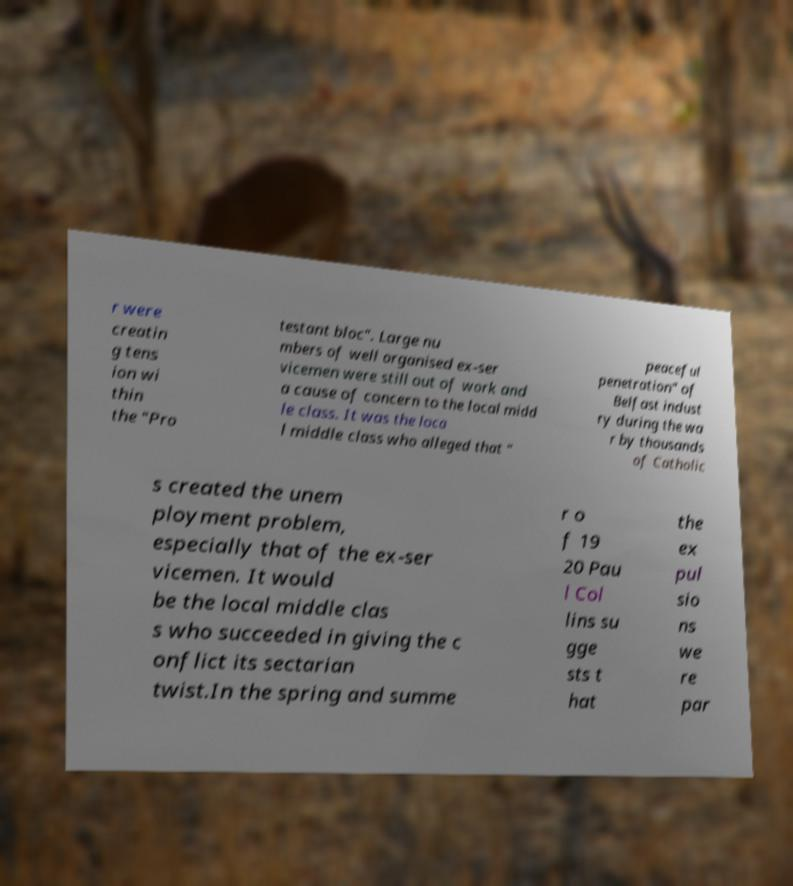Please read and relay the text visible in this image. What does it say? r were creatin g tens ion wi thin the "Pro testant bloc". Large nu mbers of well organised ex-ser vicemen were still out of work and a cause of concern to the local midd le class. It was the loca l middle class who alleged that " peaceful penetration" of Belfast indust ry during the wa r by thousands of Catholic s created the unem ployment problem, especially that of the ex-ser vicemen. It would be the local middle clas s who succeeded in giving the c onflict its sectarian twist.In the spring and summe r o f 19 20 Pau l Col lins su gge sts t hat the ex pul sio ns we re par 